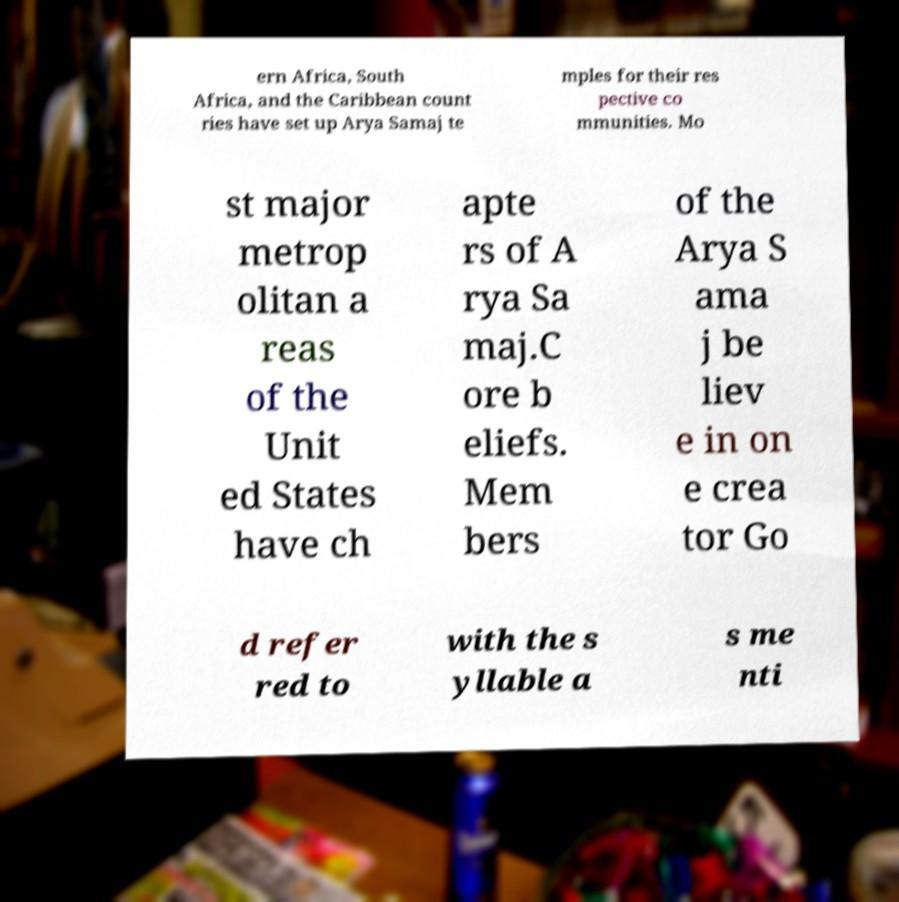There's text embedded in this image that I need extracted. Can you transcribe it verbatim? ern Africa, South Africa, and the Caribbean count ries have set up Arya Samaj te mples for their res pective co mmunities. Mo st major metrop olitan a reas of the Unit ed States have ch apte rs of A rya Sa maj.C ore b eliefs. Mem bers of the Arya S ama j be liev e in on e crea tor Go d refer red to with the s yllable a s me nti 